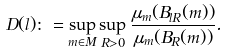Convert formula to latex. <formula><loc_0><loc_0><loc_500><loc_500>D ( l ) \colon = \sup _ { m \in M } \sup _ { R > 0 } \frac { \mu _ { m } ( B _ { l R } ( m ) ) } { \mu _ { m } ( B _ { R } ( m ) ) } .</formula> 